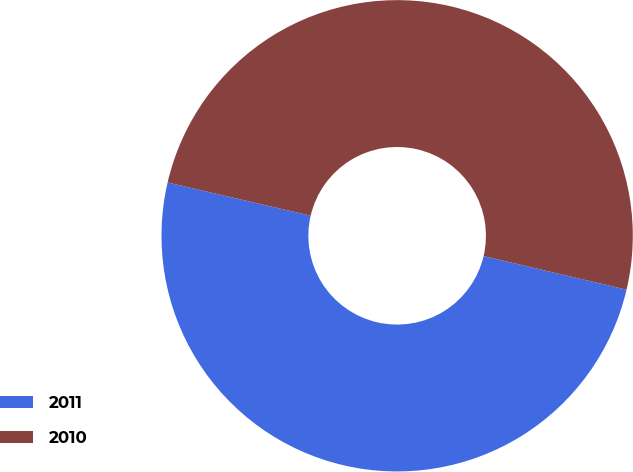Convert chart to OTSL. <chart><loc_0><loc_0><loc_500><loc_500><pie_chart><fcel>2011<fcel>2010<nl><fcel>49.96%<fcel>50.04%<nl></chart> 